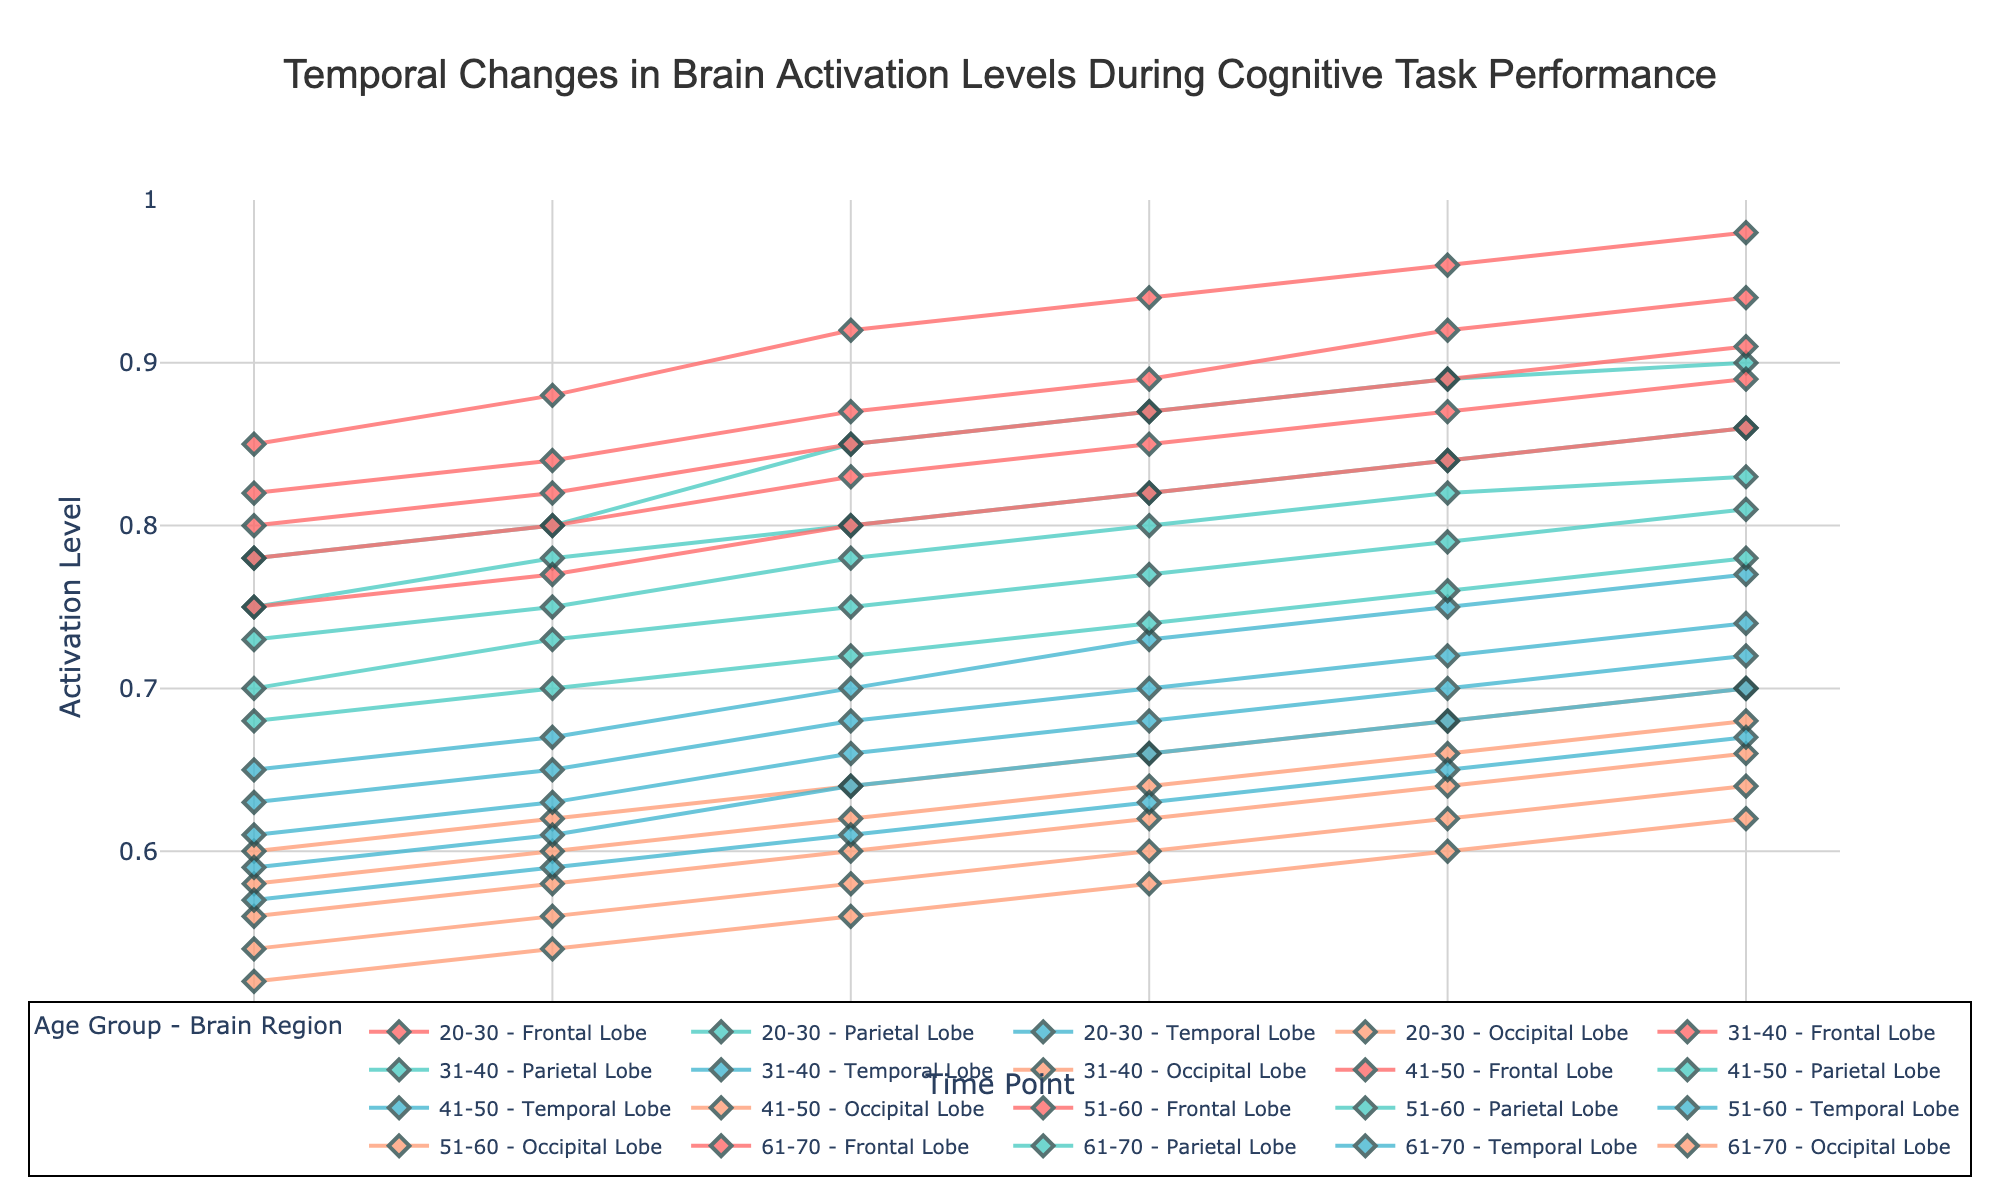What's the title of the plot? The title of the plot is written at the top center and provides an overview of what the plot represents.
Answer: Temporal Changes in Brain Activation Levels During Cognitive Task Performance How many time points are represented in the plot? The x-axis represents the time points, and there are markers on the axis indicating the number of points.
Answer: 6 Which age group shows the highest frontal lobe activation at time point 5? By examining the traces on the plot, we can see which age group has the highest activation for the frontal lobe at time point 5. The 20-30 age group's trace reaches the highest point at time point 5 in the frontal lobe.
Answer: 20-30 What is the range of activation levels on the y-axis? The y-axis range is indicated by the minimum and maximum values displayed along the axis.
Answer: 0.5 to 1 Does the parietal lobe activation in the 31-40 age group ever surpass 0.85? To determine this, we observe the parietal lobe traces for the 31-40 age group across all time points. The highest value for the parietal lobe in this age group is 0.86 at time point 5.
Answer: Yes What is the activation level difference in the temporal lobe at time point 0 between the 20-30 and 61-70 age groups? We need to find the temporal lobe activation levels for both age groups at time point 0 and compute the difference: 0.65 (20-30) - 0.57 (61-70).
Answer: 0.08 Which brain region and age group show the slowest increase in activation over time? By comparing the slopes of the activation lines, we can identify which brain region and age group have the flattest (least steep) curve over time. The occipital lobe of the 61-70 age group seems to increase the slowest.
Answer: Occipital lobe of the 61-70 age group What is the average frontal lobe activation level across all time points for the 41-50 age group? Sum the frontal lobe activation levels for the 41-50 age group (0.80 + 0.82 + 0.85 + 0.87 + 0.89 + 0.91) and divide by the number of time points (6). Calculation: (0.80 + 0.82 + 0.85 + 0.87 + 0.89 + 0.91) / 6 = 5.14 / 6 ≈ 0.86.
Answer: 0.86 